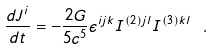Convert formula to latex. <formula><loc_0><loc_0><loc_500><loc_500>\frac { d { J } ^ { i } } { d t } = - \frac { 2 G } { 5 c ^ { 5 } } \epsilon ^ { i j k } I ^ { ( 2 ) j l } I ^ { ( 3 ) k l } \ .</formula> 